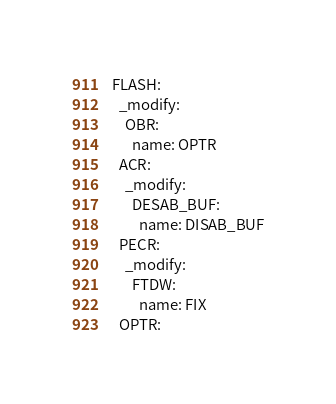Convert code to text. <code><loc_0><loc_0><loc_500><loc_500><_YAML_>
FLASH:
  _modify:
    OBR:
      name: OPTR
  ACR:
    _modify:
      DESAB_BUF:
        name: DISAB_BUF
  PECR:
    _modify:
      FTDW:
        name: FIX
  OPTR:</code> 